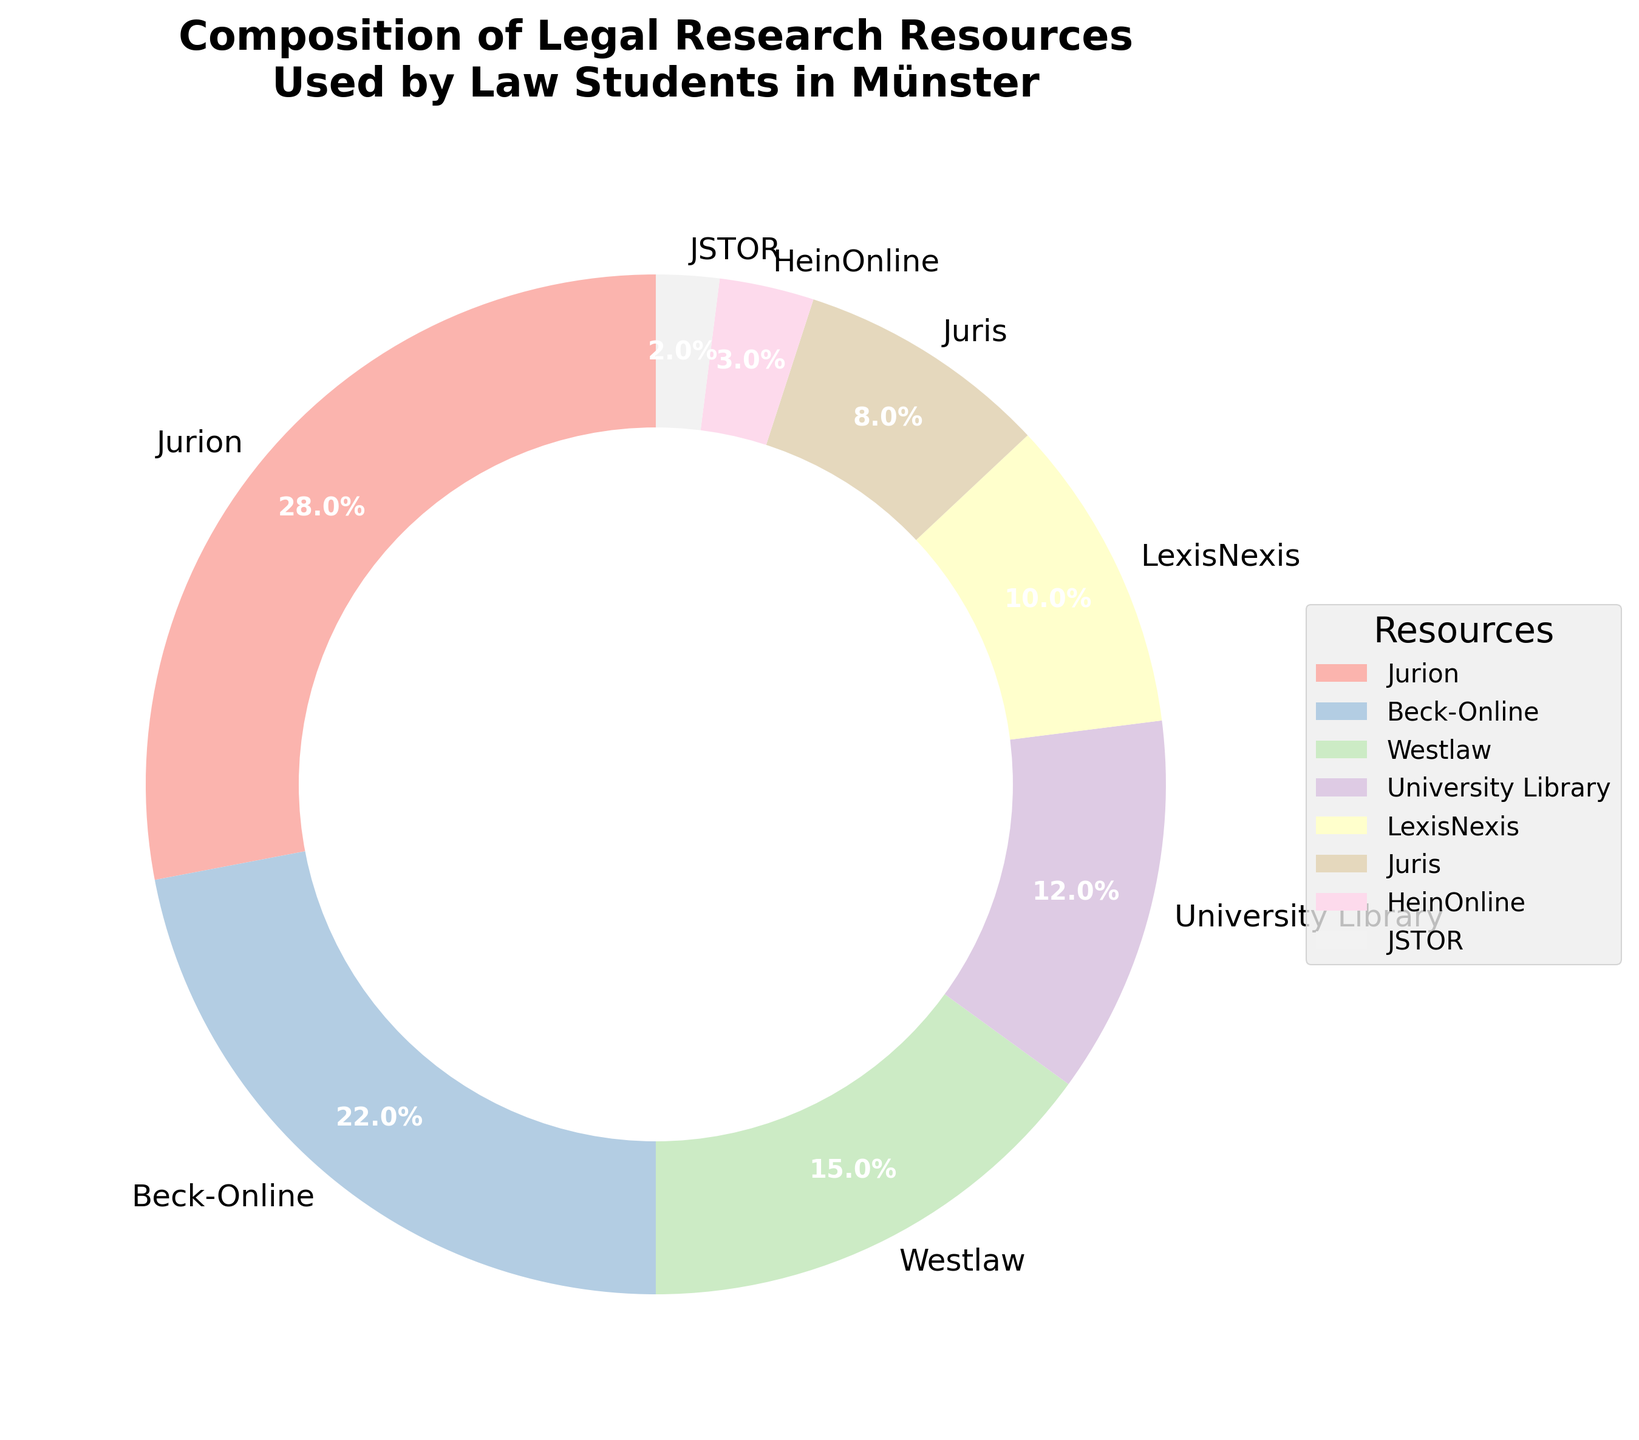What are the two most frequently used resources by law students in Münster? First, identify the slices with the largest percentages in the pie chart. Jurion (28%) and Beck-Online (22%) are the biggest, making them the most frequently used resources.
Answer: Jurion and Beck-Online How does the usage of the University Library compare to the combined usage of JSTOR and HeinOnline? First, identify the percentages: University Library (12%), JSTOR (2%), and HeinOnline (3%). Sum JSTOR and HeinOnline (2% + 3% = 5%). University Library usage (12%) is higher than the combined JSTOR and HeinOnline usage (5%).
Answer: Higher What percentage of resources used by law students comes from LexisNexis and Juris combined? Identify the percentages for LexisNexis (10%) and Juris (8%), then sum them (10% + 8% = 18%).
Answer: 18% Which resource is utilized half as much as Beck-Online? First, find the percentage of Beck-Online (22%). Half of 22% is 11%. The closest value is University Library at 12%, but it is not exactly half. The closest exact match is HeinOnline, which is approximately 7.5%, but it is too small.
Answer: None What is the smallest slice in the chart, and what percentage does it represent? Identify the smallest slice by comparing the percentages. JSTOR is the smallest slice with 2%.
Answer: JSTOR, 2% Which resources combined make up more than 50% of the total usage? Start adding the highest percentages until surpassing 50%. Jurion (28%) + Beck-Online (22%) = 50%. Adding any more resources will surpass 50%.
Answer: Jurion and Beck-Online Does the combined percentage of Westlaw, LexisNexis, and Juris exceed that of Jurion alone? Identify the percentages: Westlaw (15%), LexisNexis (10%), and Juris (8%), then sum them (15% + 10% + 8% = 33%). Compare with Jurion (28%). The combined percentage (33%) is higher than Jurion's percentage (28%).
Answer: Yes Rank the top three resources used by law students in Münster. Identify the slices with the largest percentages in descending order: Jurion (28%), Beck-Online (22%), and Westlaw (15%).
Answer: Jurion, Beck-Online, Westlaw What percentage of the resources is not covered by Jurion, Beck-Online, and Westlaw? Identify the percentages of Jurion (28%), Beck-Online (22%), and Westlaw (15%), then sum them (28% + 22% + 15% = 65%). Subtract from 100% (100% - 65% = 35%).
Answer: 35% Which resource has a similar usage percentage to Juris? Identify the percentage for Juris (8%) and find the closest percentage among other resources. LexisNexis, with 10%, is the closest but still higher than Juris.
Answer: None 